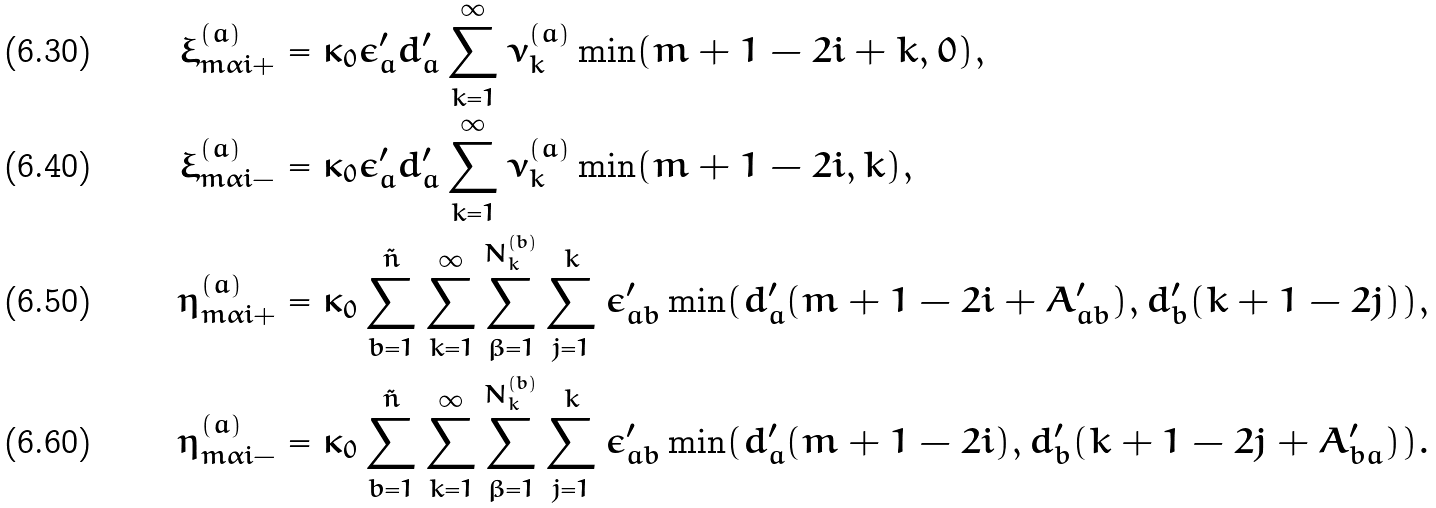<formula> <loc_0><loc_0><loc_500><loc_500>\xi ^ { ( a ) } _ { m \alpha i + } & = \kappa _ { 0 } \epsilon ^ { \prime } _ { a } d ^ { \prime } _ { a } \sum _ { k = 1 } ^ { \infty } \nu ^ { ( a ) } _ { k } \min ( m + 1 - 2 i + k , 0 ) , \\ \xi ^ { ( a ) } _ { m \alpha i - } & = \kappa _ { 0 } \epsilon ^ { \prime } _ { a } d ^ { \prime } _ { a } \sum _ { k = 1 } ^ { \infty } \nu ^ { ( a ) } _ { k } \min ( m + 1 - 2 i , k ) , \\ \eta ^ { ( a ) } _ { m \alpha i + } & = \kappa _ { 0 } \sum _ { b = 1 } ^ { \tilde { n } } \sum _ { k = 1 } ^ { \infty } \sum _ { \beta = 1 } ^ { N ^ { ( b ) } _ { k } } \sum _ { j = 1 } ^ { k } \epsilon ^ { \prime } _ { a b } \min ( d ^ { \prime } _ { a } ( m + 1 - 2 i + A ^ { \prime } _ { a b } ) , d ^ { \prime } _ { b } ( k + 1 - 2 j ) ) , \\ \eta ^ { ( a ) } _ { m \alpha i - } & = \kappa _ { 0 } \sum _ { b = 1 } ^ { \tilde { n } } \sum _ { k = 1 } ^ { \infty } \sum _ { \beta = 1 } ^ { N ^ { ( b ) } _ { k } } \sum _ { j = 1 } ^ { k } \epsilon ^ { \prime } _ { a b } \min ( d ^ { \prime } _ { a } ( m + 1 - 2 i ) , d ^ { \prime } _ { b } ( k + 1 - 2 j + A ^ { \prime } _ { b a } ) ) .</formula> 